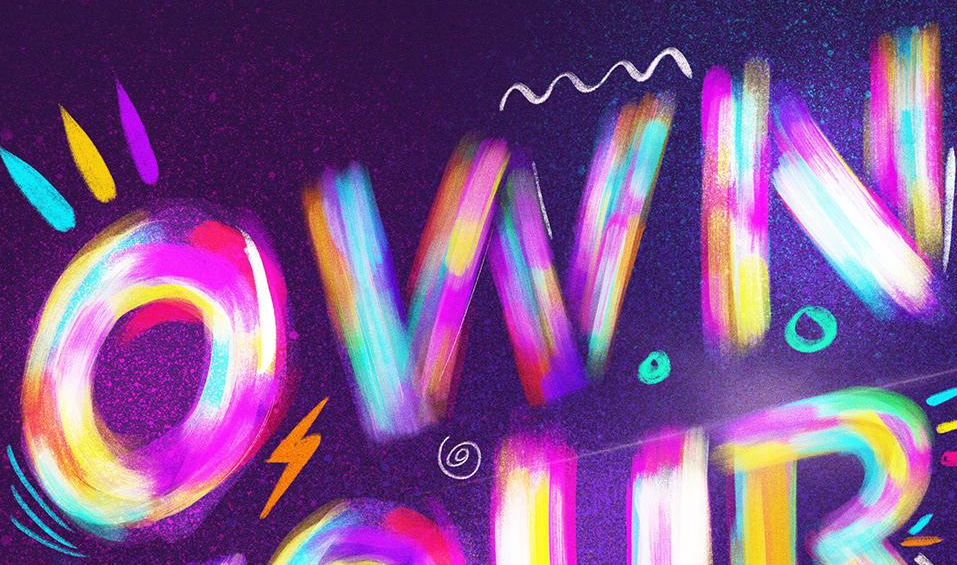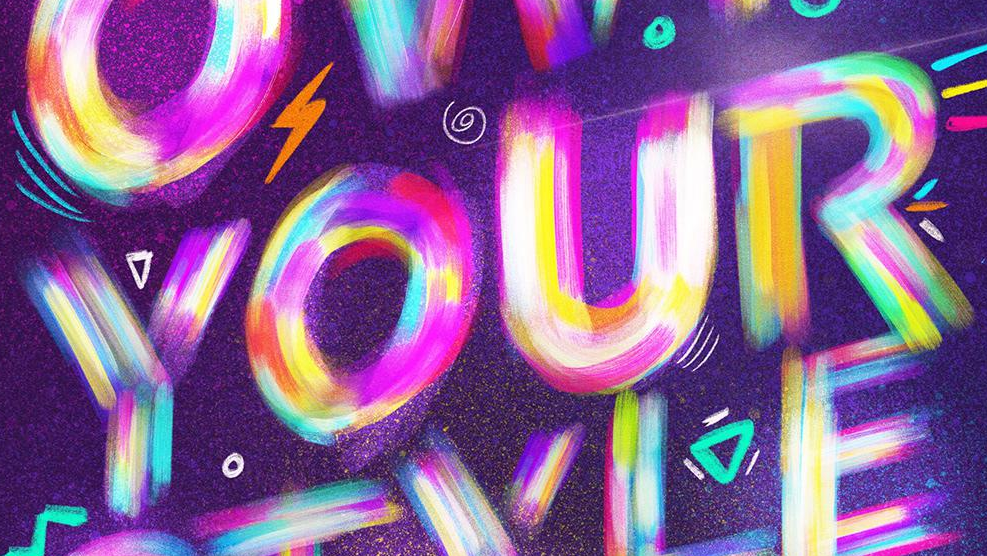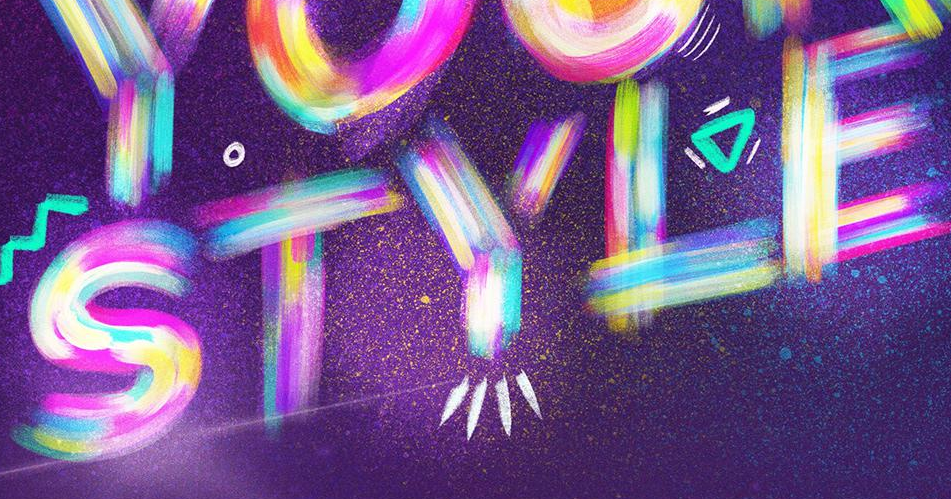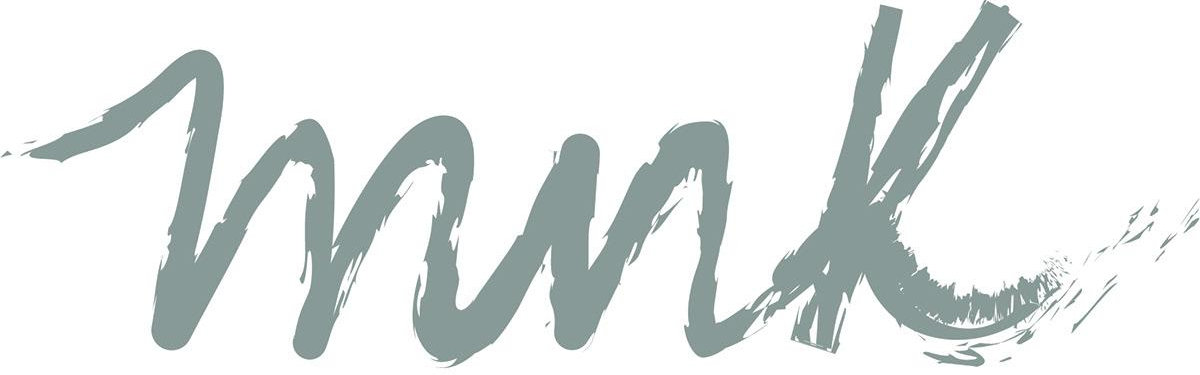Read the text from these images in sequence, separated by a semicolon. OWN; YOUR; STYLE; mnk 